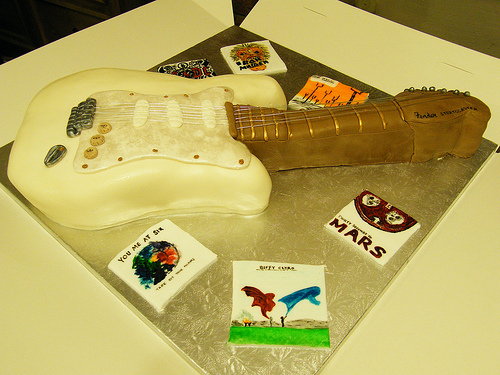<image>
Can you confirm if the guitar is in the box? Yes. The guitar is contained within or inside the box, showing a containment relationship. 